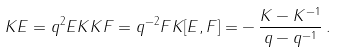<formula> <loc_0><loc_0><loc_500><loc_500>K E = q ^ { 2 } E K K F = q ^ { - 2 } F K [ E , F ] = - \, \frac { K - K ^ { - 1 } } { q - q ^ { - 1 } } \, .</formula> 